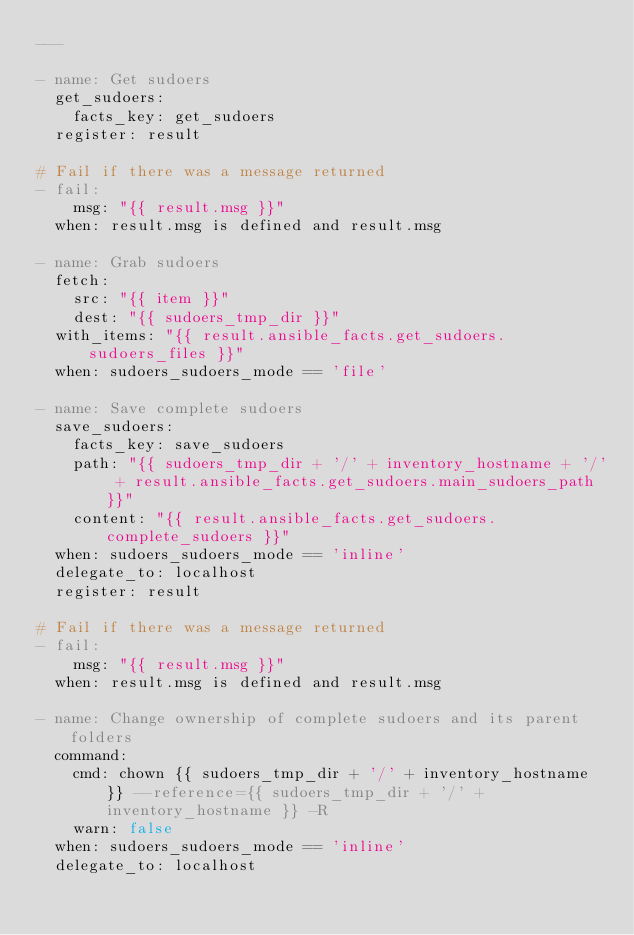<code> <loc_0><loc_0><loc_500><loc_500><_YAML_>---

- name: Get sudoers
  get_sudoers:
    facts_key: get_sudoers
  register: result

# Fail if there was a message returned
- fail:
    msg: "{{ result.msg }}"
  when: result.msg is defined and result.msg

- name: Grab sudoers
  fetch:
    src: "{{ item }}"
    dest: "{{ sudoers_tmp_dir }}"
  with_items: "{{ result.ansible_facts.get_sudoers.sudoers_files }}"
  when: sudoers_sudoers_mode == 'file'

- name: Save complete sudoers
  save_sudoers:
    facts_key: save_sudoers
    path: "{{ sudoers_tmp_dir + '/' + inventory_hostname + '/' + result.ansible_facts.get_sudoers.main_sudoers_path }}"
    content: "{{ result.ansible_facts.get_sudoers.complete_sudoers }}"
  when: sudoers_sudoers_mode == 'inline'
  delegate_to: localhost
  register: result

# Fail if there was a message returned
- fail:
    msg: "{{ result.msg }}"
  when: result.msg is defined and result.msg

- name: Change ownership of complete sudoers and its parent folders
  command:
    cmd: chown {{ sudoers_tmp_dir + '/' + inventory_hostname }} --reference={{ sudoers_tmp_dir + '/' + inventory_hostname }} -R
    warn: false
  when: sudoers_sudoers_mode == 'inline'
  delegate_to: localhost

</code> 